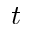Convert formula to latex. <formula><loc_0><loc_0><loc_500><loc_500>t</formula> 